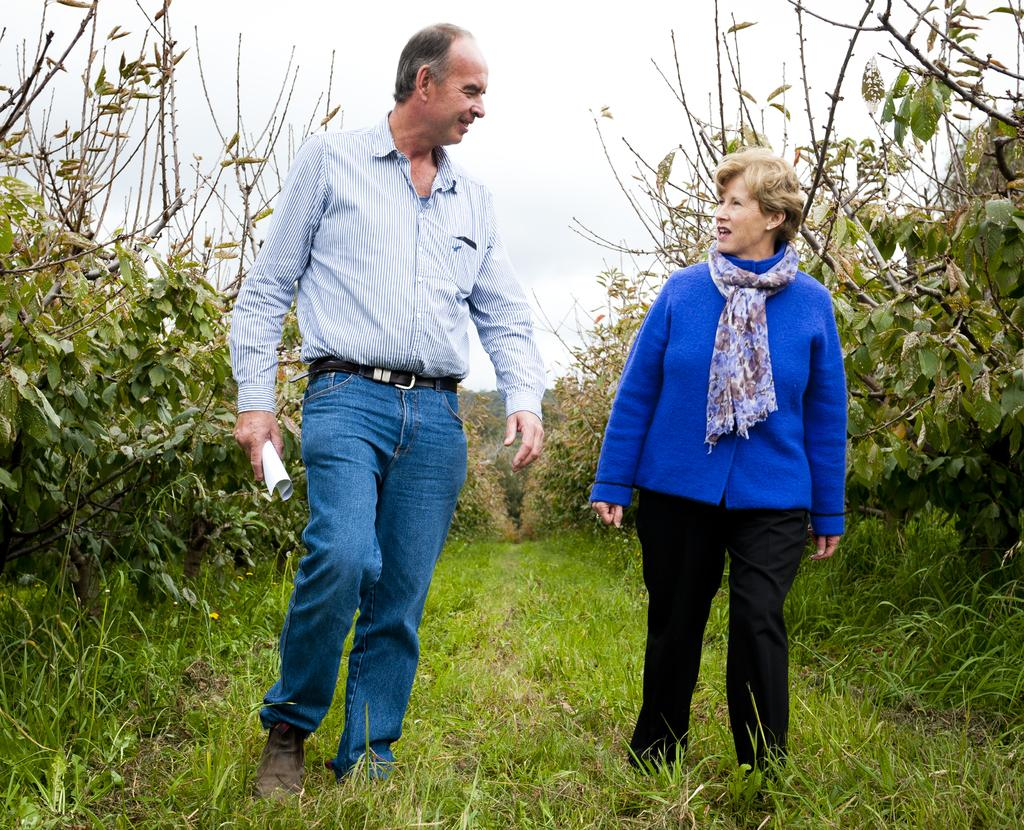How many people are in the image? There are two people standing in the image. What is the surface they are standing on? The people are standing on the grass. What type of vegetation can be seen on both sides of the image? There are plants on both sides of the image. What can be seen in the background of the image? The sky is visible in the background of the image. What type of leather is visible on the people in the image? There is no leather visible on the people in the image. How does the wind affect the plants in the image? The image does not provide information about the wind, so we cannot determine its effect on the plants. 